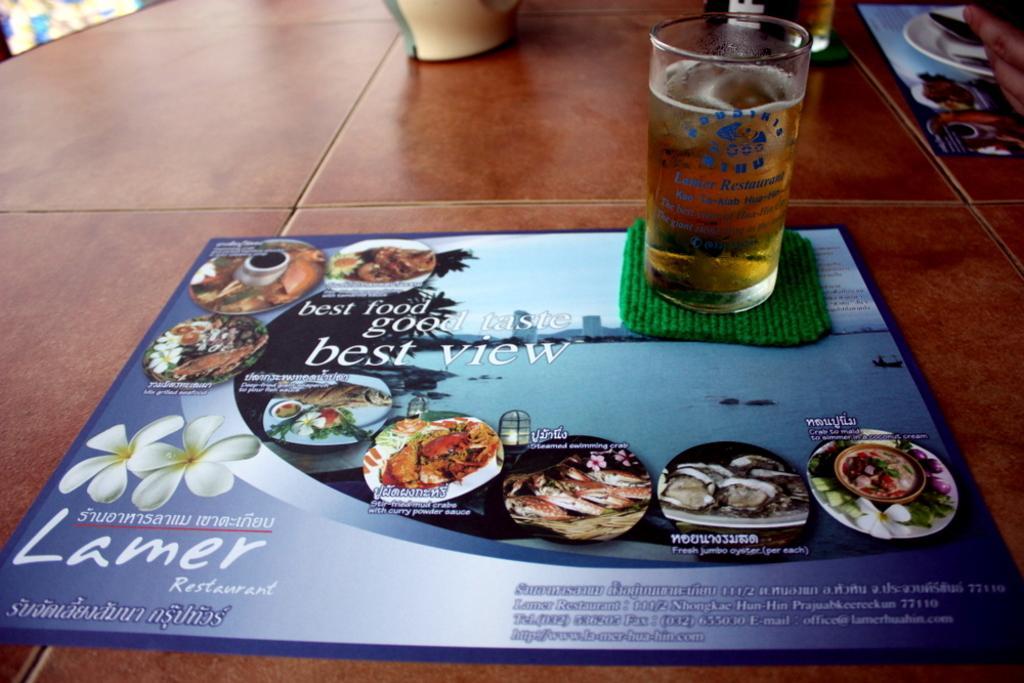Can you describe this image briefly? In this picture we can see a glass with a drink into, a board, plate , spoon and person's hand on the table. 